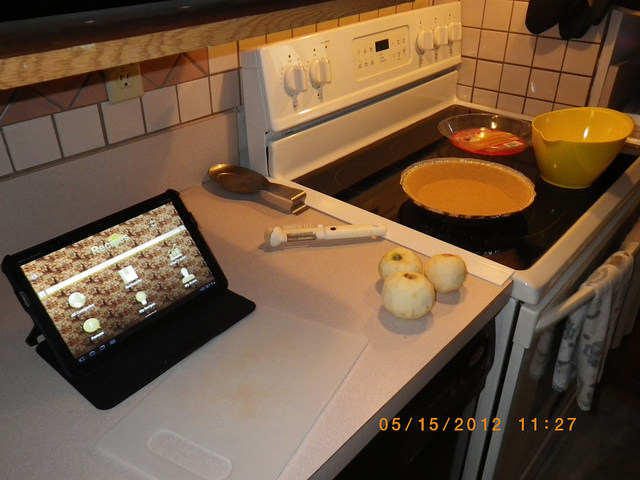Please identify all text content in this image. 05 15 2012 11 27 